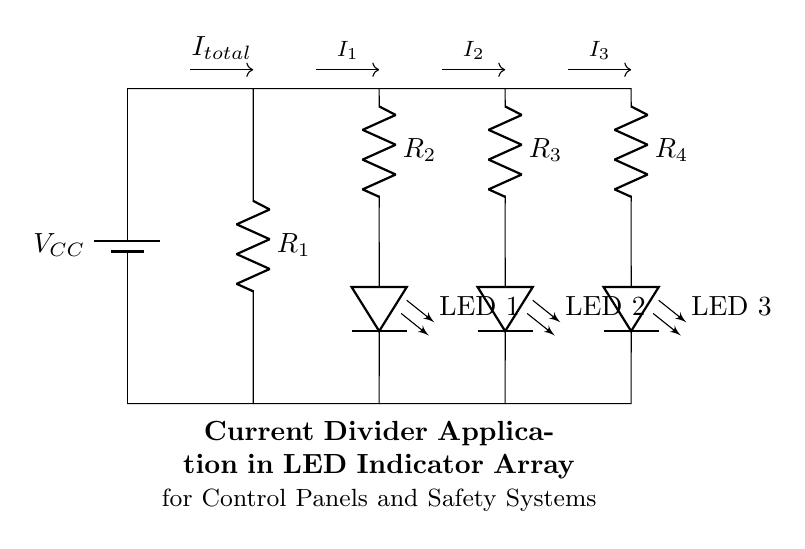What is the total current entering the circuit? The total current entering the circuit is represented as I total, which denotes the sum of the currents flowing through the parallel branches.
Answer: I total How many LED indicators are in the circuit? The circuit diagram depicts three LED indicators, labeled as LED 1, LED 2, and LED 3, indicating there are three distinct lights present.
Answer: 3 What is the function of the resistors in the current divider? The resistors (R 2, R 3, and R 4) in the circuit function to split the total current into different paths, allowing for controlled current through each LED indicator while maintaining the necessary voltage.
Answer: Current splitting What happens to the brightness of the LEDs if R2 is replaced with a lower value resistor? If R 2 is replaced with a lower value resistor, the current through LED 1 will increase, leading to an increase in its brightness due to the reduced resistance in that branch, allowing more current flow.
Answer: Increases brightness How is the current distributed among the LEDs? The current distribution among the LEDs is determined by the resistance values of R 2, R 3, and R 4 based on the current divider rule, which states the current is inversely proportional to the resistor values in parallel.
Answer: Inversely proportional What type of circuit is represented in the diagram? The circuit depicted in the diagram is a current divider circuit, which is characterized by its ability to split the total current into different branches based on their respective resistances.
Answer: Current divider 